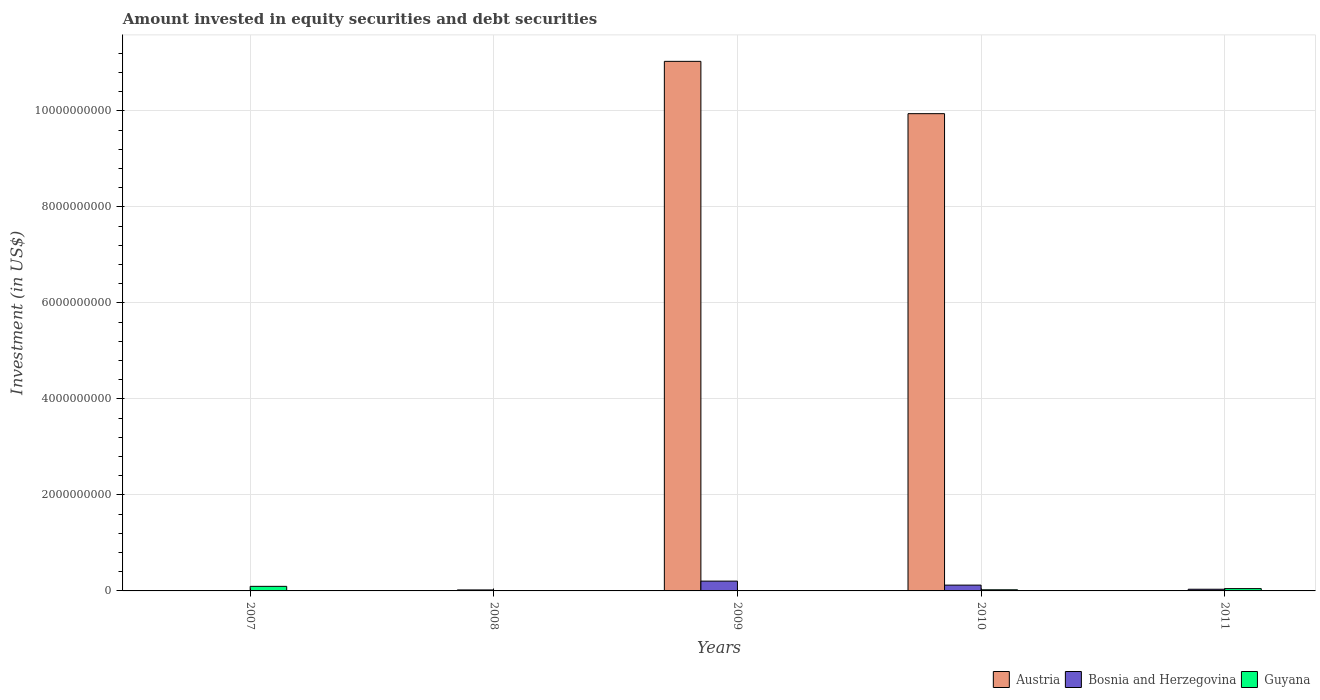How many different coloured bars are there?
Provide a short and direct response. 3. Are the number of bars per tick equal to the number of legend labels?
Your answer should be very brief. No. How many bars are there on the 1st tick from the left?
Your answer should be very brief. 2. What is the label of the 2nd group of bars from the left?
Ensure brevity in your answer.  2008. In how many cases, is the number of bars for a given year not equal to the number of legend labels?
Keep it short and to the point. 4. What is the amount invested in equity securities and debt securities in Bosnia and Herzegovina in 2008?
Provide a short and direct response. 2.07e+07. Across all years, what is the maximum amount invested in equity securities and debt securities in Bosnia and Herzegovina?
Make the answer very short. 2.04e+08. Across all years, what is the minimum amount invested in equity securities and debt securities in Guyana?
Make the answer very short. 0. What is the total amount invested in equity securities and debt securities in Bosnia and Herzegovina in the graph?
Your answer should be very brief. 3.84e+08. What is the difference between the amount invested in equity securities and debt securities in Bosnia and Herzegovina in 2007 and that in 2010?
Your answer should be compact. -1.18e+08. What is the difference between the amount invested in equity securities and debt securities in Bosnia and Herzegovina in 2010 and the amount invested in equity securities and debt securities in Austria in 2009?
Offer a terse response. -1.09e+1. What is the average amount invested in equity securities and debt securities in Bosnia and Herzegovina per year?
Offer a very short reply. 7.67e+07. In the year 2010, what is the difference between the amount invested in equity securities and debt securities in Guyana and amount invested in equity securities and debt securities in Bosnia and Herzegovina?
Offer a very short reply. -9.75e+07. In how many years, is the amount invested in equity securities and debt securities in Guyana greater than 7200000000 US$?
Keep it short and to the point. 0. What is the ratio of the amount invested in equity securities and debt securities in Bosnia and Herzegovina in 2007 to that in 2008?
Give a very brief answer. 0.13. Is the amount invested in equity securities and debt securities in Bosnia and Herzegovina in 2009 less than that in 2010?
Keep it short and to the point. No. Is the difference between the amount invested in equity securities and debt securities in Guyana in 2007 and 2010 greater than the difference between the amount invested in equity securities and debt securities in Bosnia and Herzegovina in 2007 and 2010?
Ensure brevity in your answer.  Yes. What is the difference between the highest and the second highest amount invested in equity securities and debt securities in Bosnia and Herzegovina?
Your response must be concise. 8.31e+07. What is the difference between the highest and the lowest amount invested in equity securities and debt securities in Bosnia and Herzegovina?
Ensure brevity in your answer.  2.01e+08. Is the sum of the amount invested in equity securities and debt securities in Bosnia and Herzegovina in 2007 and 2011 greater than the maximum amount invested in equity securities and debt securities in Guyana across all years?
Your answer should be compact. No. Is it the case that in every year, the sum of the amount invested in equity securities and debt securities in Bosnia and Herzegovina and amount invested in equity securities and debt securities in Guyana is greater than the amount invested in equity securities and debt securities in Austria?
Offer a very short reply. No. How many years are there in the graph?
Offer a very short reply. 5. Are the values on the major ticks of Y-axis written in scientific E-notation?
Provide a succinct answer. No. Does the graph contain any zero values?
Provide a short and direct response. Yes. Where does the legend appear in the graph?
Keep it short and to the point. Bottom right. How are the legend labels stacked?
Give a very brief answer. Horizontal. What is the title of the graph?
Offer a terse response. Amount invested in equity securities and debt securities. Does "West Bank and Gaza" appear as one of the legend labels in the graph?
Offer a very short reply. No. What is the label or title of the Y-axis?
Provide a succinct answer. Investment (in US$). What is the Investment (in US$) in Bosnia and Herzegovina in 2007?
Your answer should be compact. 2.70e+06. What is the Investment (in US$) in Guyana in 2007?
Your answer should be compact. 9.51e+07. What is the Investment (in US$) in Bosnia and Herzegovina in 2008?
Provide a short and direct response. 2.07e+07. What is the Investment (in US$) of Guyana in 2008?
Your answer should be compact. 0. What is the Investment (in US$) of Austria in 2009?
Provide a short and direct response. 1.10e+1. What is the Investment (in US$) of Bosnia and Herzegovina in 2009?
Provide a succinct answer. 2.04e+08. What is the Investment (in US$) of Guyana in 2009?
Keep it short and to the point. 0. What is the Investment (in US$) in Austria in 2010?
Provide a short and direct response. 9.94e+09. What is the Investment (in US$) of Bosnia and Herzegovina in 2010?
Your answer should be very brief. 1.21e+08. What is the Investment (in US$) of Guyana in 2010?
Provide a succinct answer. 2.35e+07. What is the Investment (in US$) in Bosnia and Herzegovina in 2011?
Make the answer very short. 3.49e+07. What is the Investment (in US$) of Guyana in 2011?
Provide a short and direct response. 4.83e+07. Across all years, what is the maximum Investment (in US$) of Austria?
Provide a succinct answer. 1.10e+1. Across all years, what is the maximum Investment (in US$) of Bosnia and Herzegovina?
Offer a very short reply. 2.04e+08. Across all years, what is the maximum Investment (in US$) of Guyana?
Offer a terse response. 9.51e+07. Across all years, what is the minimum Investment (in US$) in Bosnia and Herzegovina?
Keep it short and to the point. 2.70e+06. What is the total Investment (in US$) in Austria in the graph?
Provide a succinct answer. 2.10e+1. What is the total Investment (in US$) of Bosnia and Herzegovina in the graph?
Your answer should be very brief. 3.84e+08. What is the total Investment (in US$) in Guyana in the graph?
Give a very brief answer. 1.67e+08. What is the difference between the Investment (in US$) in Bosnia and Herzegovina in 2007 and that in 2008?
Your answer should be compact. -1.80e+07. What is the difference between the Investment (in US$) of Bosnia and Herzegovina in 2007 and that in 2009?
Provide a short and direct response. -2.01e+08. What is the difference between the Investment (in US$) in Bosnia and Herzegovina in 2007 and that in 2010?
Your answer should be very brief. -1.18e+08. What is the difference between the Investment (in US$) of Guyana in 2007 and that in 2010?
Your answer should be compact. 7.16e+07. What is the difference between the Investment (in US$) in Bosnia and Herzegovina in 2007 and that in 2011?
Offer a terse response. -3.22e+07. What is the difference between the Investment (in US$) of Guyana in 2007 and that in 2011?
Offer a very short reply. 4.68e+07. What is the difference between the Investment (in US$) in Bosnia and Herzegovina in 2008 and that in 2009?
Keep it short and to the point. -1.83e+08. What is the difference between the Investment (in US$) in Bosnia and Herzegovina in 2008 and that in 2010?
Your answer should be compact. -1.00e+08. What is the difference between the Investment (in US$) in Bosnia and Herzegovina in 2008 and that in 2011?
Give a very brief answer. -1.42e+07. What is the difference between the Investment (in US$) in Austria in 2009 and that in 2010?
Provide a succinct answer. 1.09e+09. What is the difference between the Investment (in US$) in Bosnia and Herzegovina in 2009 and that in 2010?
Keep it short and to the point. 8.31e+07. What is the difference between the Investment (in US$) in Bosnia and Herzegovina in 2009 and that in 2011?
Keep it short and to the point. 1.69e+08. What is the difference between the Investment (in US$) in Bosnia and Herzegovina in 2010 and that in 2011?
Offer a very short reply. 8.61e+07. What is the difference between the Investment (in US$) of Guyana in 2010 and that in 2011?
Offer a very short reply. -2.48e+07. What is the difference between the Investment (in US$) of Bosnia and Herzegovina in 2007 and the Investment (in US$) of Guyana in 2010?
Give a very brief answer. -2.08e+07. What is the difference between the Investment (in US$) in Bosnia and Herzegovina in 2007 and the Investment (in US$) in Guyana in 2011?
Offer a terse response. -4.56e+07. What is the difference between the Investment (in US$) in Bosnia and Herzegovina in 2008 and the Investment (in US$) in Guyana in 2010?
Offer a terse response. -2.78e+06. What is the difference between the Investment (in US$) in Bosnia and Herzegovina in 2008 and the Investment (in US$) in Guyana in 2011?
Your response must be concise. -2.75e+07. What is the difference between the Investment (in US$) in Austria in 2009 and the Investment (in US$) in Bosnia and Herzegovina in 2010?
Your answer should be compact. 1.09e+1. What is the difference between the Investment (in US$) in Austria in 2009 and the Investment (in US$) in Guyana in 2010?
Your response must be concise. 1.10e+1. What is the difference between the Investment (in US$) in Bosnia and Herzegovina in 2009 and the Investment (in US$) in Guyana in 2010?
Ensure brevity in your answer.  1.81e+08. What is the difference between the Investment (in US$) of Austria in 2009 and the Investment (in US$) of Bosnia and Herzegovina in 2011?
Your response must be concise. 1.10e+1. What is the difference between the Investment (in US$) in Austria in 2009 and the Investment (in US$) in Guyana in 2011?
Your answer should be very brief. 1.10e+1. What is the difference between the Investment (in US$) in Bosnia and Herzegovina in 2009 and the Investment (in US$) in Guyana in 2011?
Provide a short and direct response. 1.56e+08. What is the difference between the Investment (in US$) of Austria in 2010 and the Investment (in US$) of Bosnia and Herzegovina in 2011?
Make the answer very short. 9.91e+09. What is the difference between the Investment (in US$) in Austria in 2010 and the Investment (in US$) in Guyana in 2011?
Offer a terse response. 9.89e+09. What is the difference between the Investment (in US$) of Bosnia and Herzegovina in 2010 and the Investment (in US$) of Guyana in 2011?
Your answer should be very brief. 7.27e+07. What is the average Investment (in US$) in Austria per year?
Give a very brief answer. 4.19e+09. What is the average Investment (in US$) in Bosnia and Herzegovina per year?
Provide a succinct answer. 7.67e+07. What is the average Investment (in US$) in Guyana per year?
Your response must be concise. 3.34e+07. In the year 2007, what is the difference between the Investment (in US$) in Bosnia and Herzegovina and Investment (in US$) in Guyana?
Make the answer very short. -9.24e+07. In the year 2009, what is the difference between the Investment (in US$) in Austria and Investment (in US$) in Bosnia and Herzegovina?
Give a very brief answer. 1.08e+1. In the year 2010, what is the difference between the Investment (in US$) of Austria and Investment (in US$) of Bosnia and Herzegovina?
Offer a very short reply. 9.82e+09. In the year 2010, what is the difference between the Investment (in US$) in Austria and Investment (in US$) in Guyana?
Give a very brief answer. 9.92e+09. In the year 2010, what is the difference between the Investment (in US$) in Bosnia and Herzegovina and Investment (in US$) in Guyana?
Offer a very short reply. 9.75e+07. In the year 2011, what is the difference between the Investment (in US$) of Bosnia and Herzegovina and Investment (in US$) of Guyana?
Provide a succinct answer. -1.33e+07. What is the ratio of the Investment (in US$) of Bosnia and Herzegovina in 2007 to that in 2008?
Offer a terse response. 0.13. What is the ratio of the Investment (in US$) in Bosnia and Herzegovina in 2007 to that in 2009?
Offer a very short reply. 0.01. What is the ratio of the Investment (in US$) of Bosnia and Herzegovina in 2007 to that in 2010?
Provide a short and direct response. 0.02. What is the ratio of the Investment (in US$) of Guyana in 2007 to that in 2010?
Keep it short and to the point. 4.05. What is the ratio of the Investment (in US$) of Bosnia and Herzegovina in 2007 to that in 2011?
Your answer should be very brief. 0.08. What is the ratio of the Investment (in US$) of Guyana in 2007 to that in 2011?
Your answer should be compact. 1.97. What is the ratio of the Investment (in US$) of Bosnia and Herzegovina in 2008 to that in 2009?
Make the answer very short. 0.1. What is the ratio of the Investment (in US$) in Bosnia and Herzegovina in 2008 to that in 2010?
Give a very brief answer. 0.17. What is the ratio of the Investment (in US$) in Bosnia and Herzegovina in 2008 to that in 2011?
Your response must be concise. 0.59. What is the ratio of the Investment (in US$) in Austria in 2009 to that in 2010?
Offer a very short reply. 1.11. What is the ratio of the Investment (in US$) in Bosnia and Herzegovina in 2009 to that in 2010?
Offer a very short reply. 1.69. What is the ratio of the Investment (in US$) in Bosnia and Herzegovina in 2009 to that in 2011?
Offer a terse response. 5.84. What is the ratio of the Investment (in US$) in Bosnia and Herzegovina in 2010 to that in 2011?
Ensure brevity in your answer.  3.46. What is the ratio of the Investment (in US$) of Guyana in 2010 to that in 2011?
Your answer should be very brief. 0.49. What is the difference between the highest and the second highest Investment (in US$) in Bosnia and Herzegovina?
Make the answer very short. 8.31e+07. What is the difference between the highest and the second highest Investment (in US$) in Guyana?
Ensure brevity in your answer.  4.68e+07. What is the difference between the highest and the lowest Investment (in US$) in Austria?
Offer a very short reply. 1.10e+1. What is the difference between the highest and the lowest Investment (in US$) of Bosnia and Herzegovina?
Offer a terse response. 2.01e+08. What is the difference between the highest and the lowest Investment (in US$) in Guyana?
Offer a very short reply. 9.51e+07. 